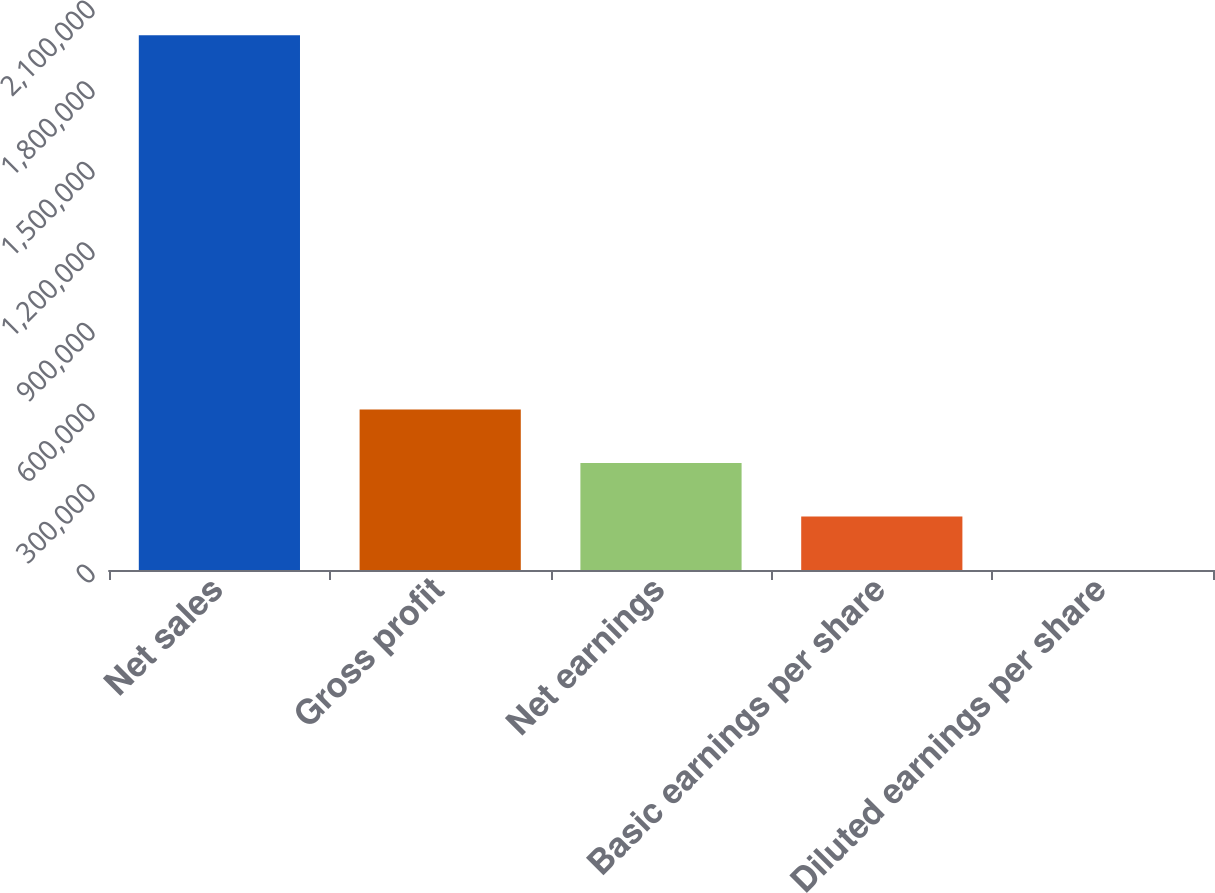<chart> <loc_0><loc_0><loc_500><loc_500><bar_chart><fcel>Net sales<fcel>Gross profit<fcel>Net earnings<fcel>Basic earnings per share<fcel>Diluted earnings per share<nl><fcel>1.99066e+06<fcel>597199<fcel>398133<fcel>199068<fcel>2.06<nl></chart> 